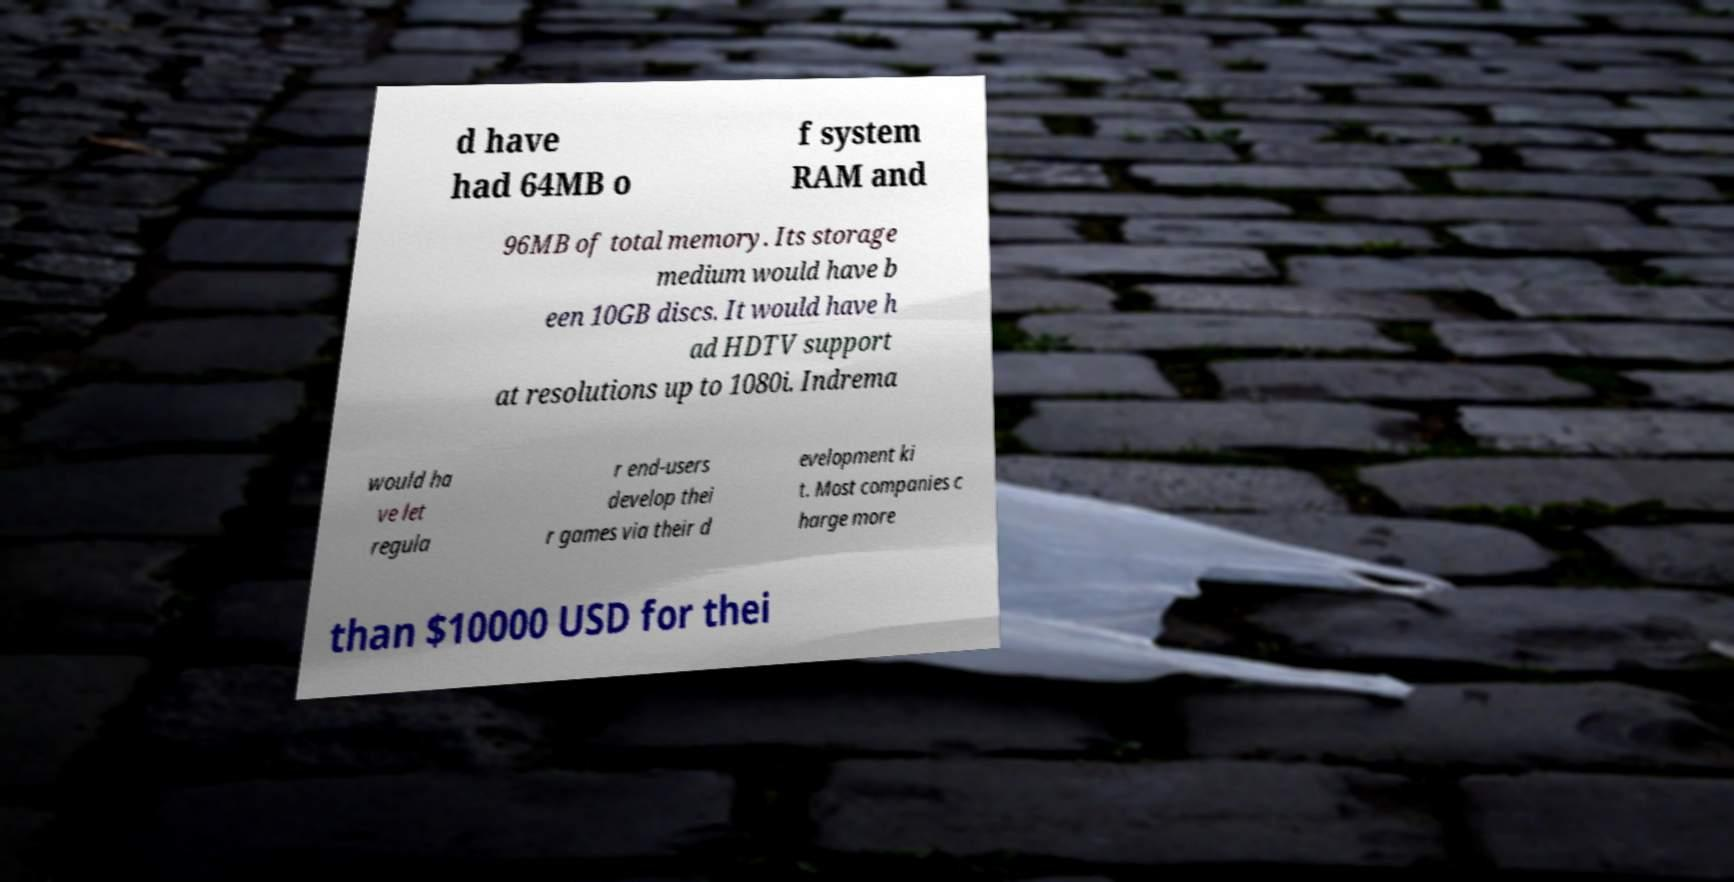Can you read and provide the text displayed in the image?This photo seems to have some interesting text. Can you extract and type it out for me? d have had 64MB o f system RAM and 96MB of total memory. Its storage medium would have b een 10GB discs. It would have h ad HDTV support at resolutions up to 1080i. Indrema would ha ve let regula r end-users develop thei r games via their d evelopment ki t. Most companies c harge more than $10000 USD for thei 